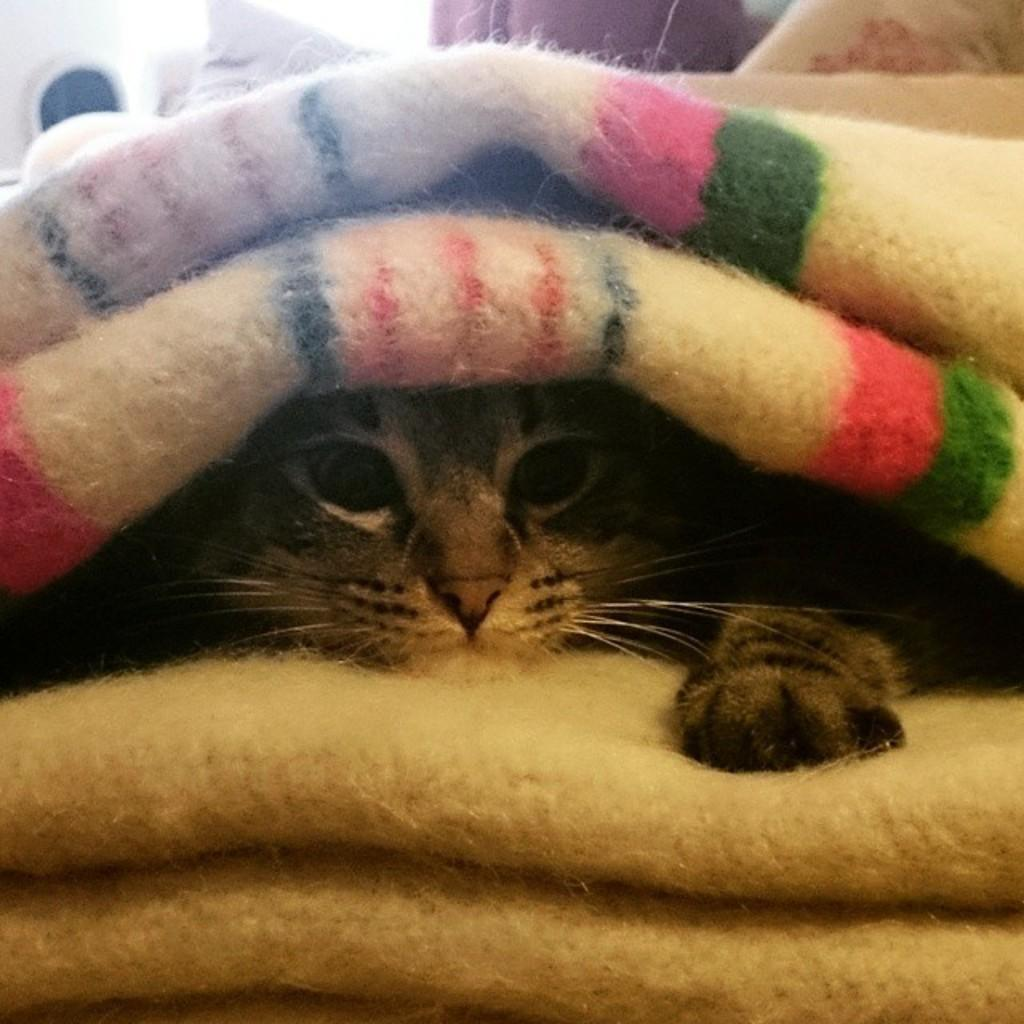What animal can be seen in the image? There is a cat in the image. Where is the cat located? The cat is sitting on a bed. What is covering the cat? There are two blankets above the cat. What can be seen at the top of the image? There is a pillow at the top of the image. What is beside the pillow? There appears to be a wall beside the pillow. Can you see any clams in the image? There are no clams present in the image. Is there a scarecrow visible in the image? There is no scarecrow present in the image. 